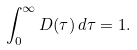Convert formula to latex. <formula><loc_0><loc_0><loc_500><loc_500>\int _ { 0 } ^ { \infty } D ( \tau ) \, d \tau = 1 .</formula> 